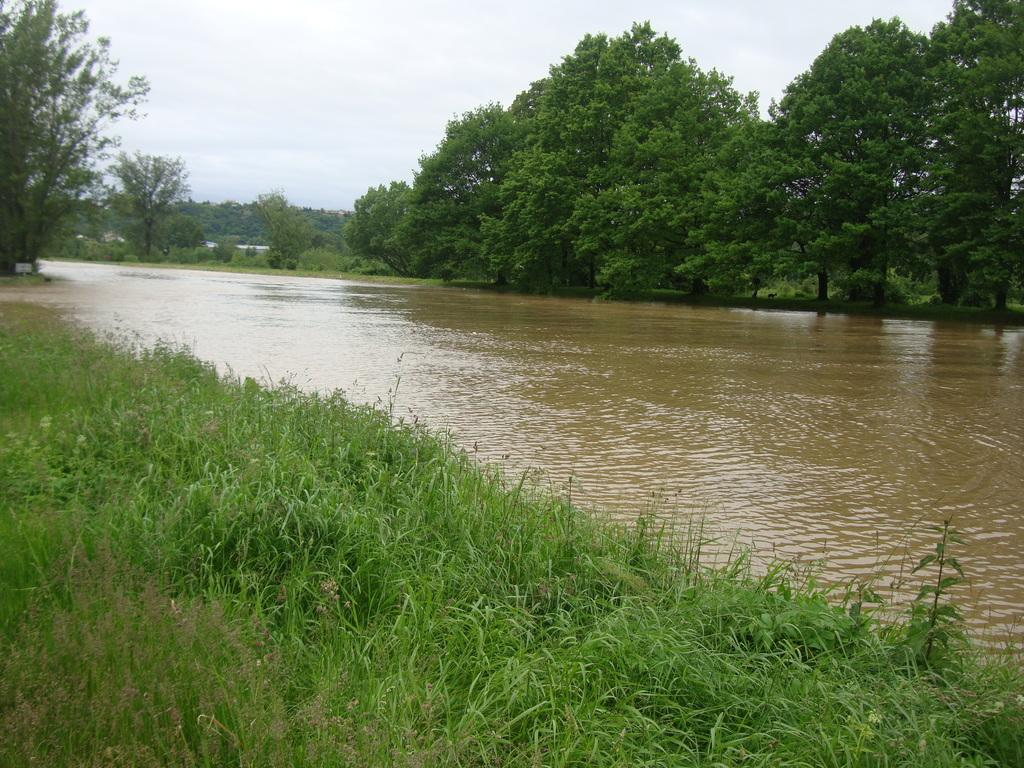What can be seen in the sky in the image? The sky with clouds is visible in the image. What type of vegetation is present in the image? There are trees in the image, and grass is also present. What kind of water feature can be seen in the image? There is a canal in the image. Where is the family sitting in the image? There is no family present in the image. What type of street is visible in the image? There is no street visible in the image. 